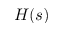<formula> <loc_0><loc_0><loc_500><loc_500>H ( s )</formula> 